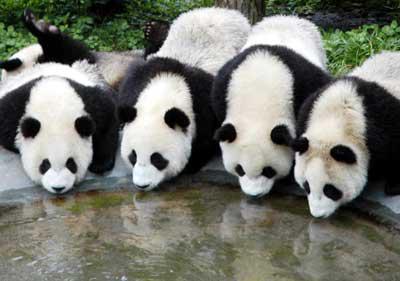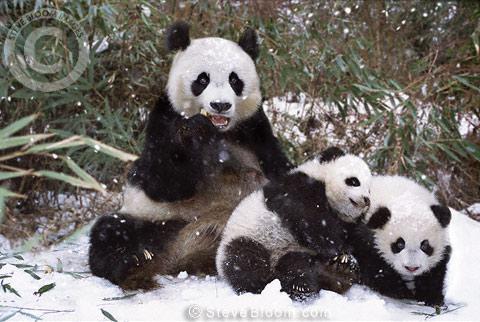The first image is the image on the left, the second image is the image on the right. Examine the images to the left and right. Is the description "There are exactly three pandas in the right image." accurate? Answer yes or no. Yes. 